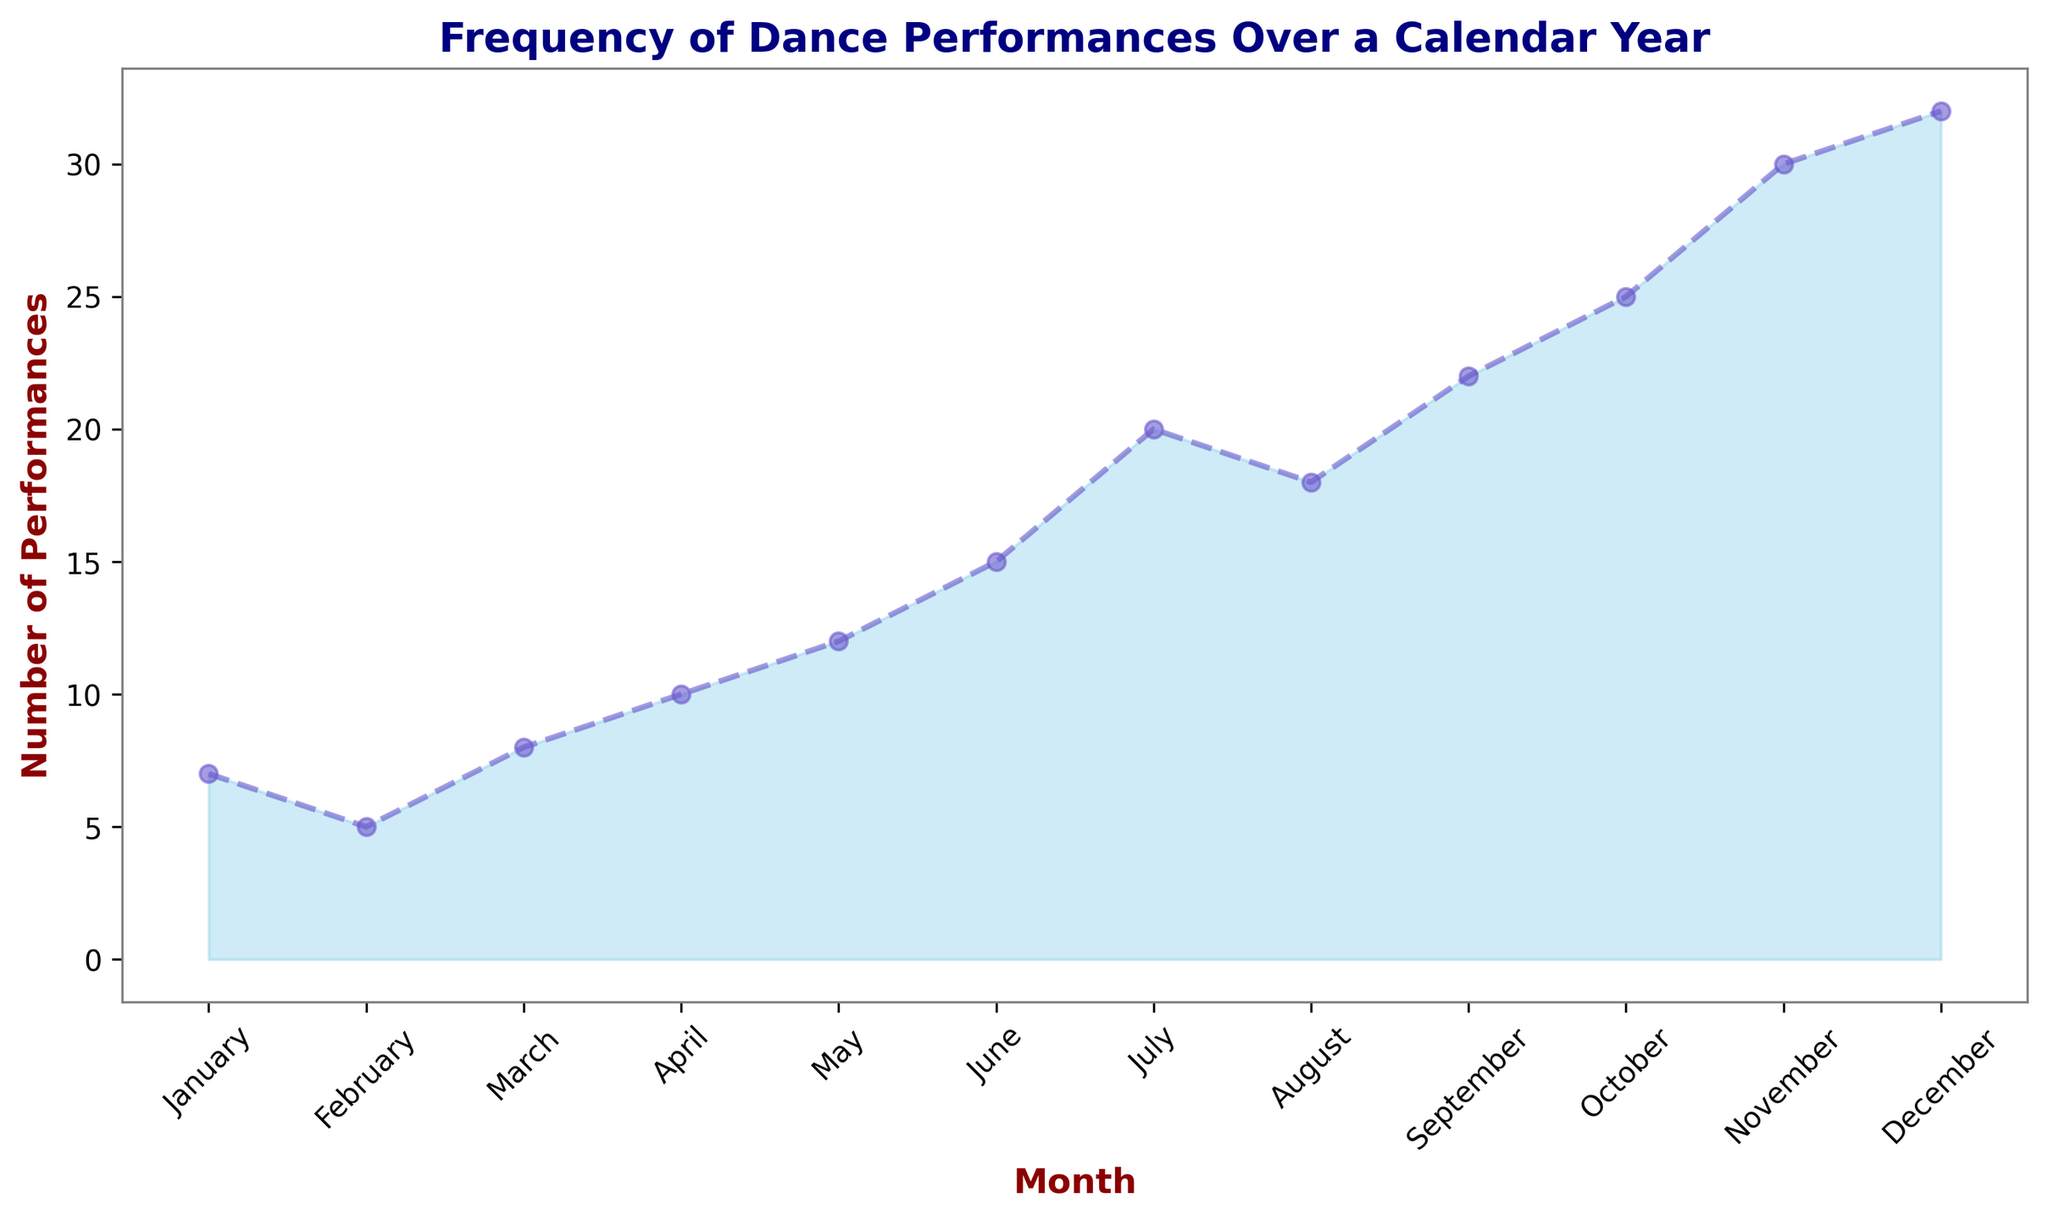What's the highest number of performances in any month? To find the highest number of performances, look at the performance counts for each month and identify the maximum value. The highest performance count is 32 in December.
Answer: 32 Which month had fewer performances, March or April? Compare the performance counts for March and April. March had 8 performances, while April had 10. Therefore, March had fewer performances.
Answer: March In which month does the number of performances first exceed 20? Scan the performance counts month-by-month. The performance count first exceeds 20 in September, which has 22 performances.
Answer: September What is the total number of performances from June to August? Sum the performance counts for June, July, and August. June has 15, July has 20, and August has 18. The total is 15 + 20 + 18 = 53.
Answer: 53 By how much did the number of performances increase from January to December? Subtract the number of performances in January from the number in December. January had 7 performances, and December had 32. The increase is 32 - 7 = 25.
Answer: 25 How does the number of performances in July compare to September? Look at the performance counts for July and September. July had 20 performances, and September had 22. Since 20 is less than 22, July had fewer performances than September.
Answer: July had fewer performances What is the average number of performances in the first half of the year? Calculate the average of the performance counts from January to June. The counts are 7, 5, 8, 10, 12, and 15. The sum is 7 + 5 + 8 + 10 + 12 + 15 = 57, and the average is 57 / 6 = 9.5.
Answer: 9.5 Describe the trend in the number of performances over the year. Observe the overall pattern in the data. The number of performances shows a general increasing trend throughout the year, starting relatively low in January and peaking in December.
Answer: Increasing trend Which quarter of the year had the most performances? Analyze performance counts by quarter. Q1 (Jan-Mar): 7+5+8=20, Q2 (Apr-Jun): 10+12+15=37, Q3 (Jul-Sep): 20+18+22=60, Q4 (Oct-Dec): 25+30+32=87. The fourth quarter had the most performances with a total of 87.
Answer: Fourth Quarter 